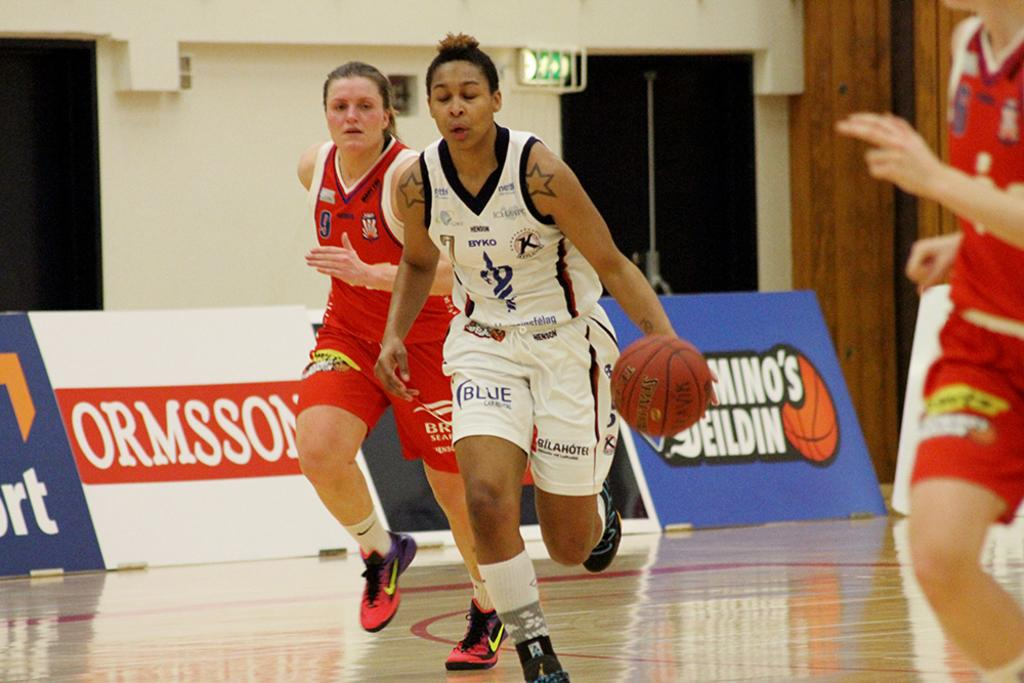<image>
Give a short and clear explanation of the subsequent image. Number 7 dribbles the ball upcourt as number 9 on the other team tries to keep up. 